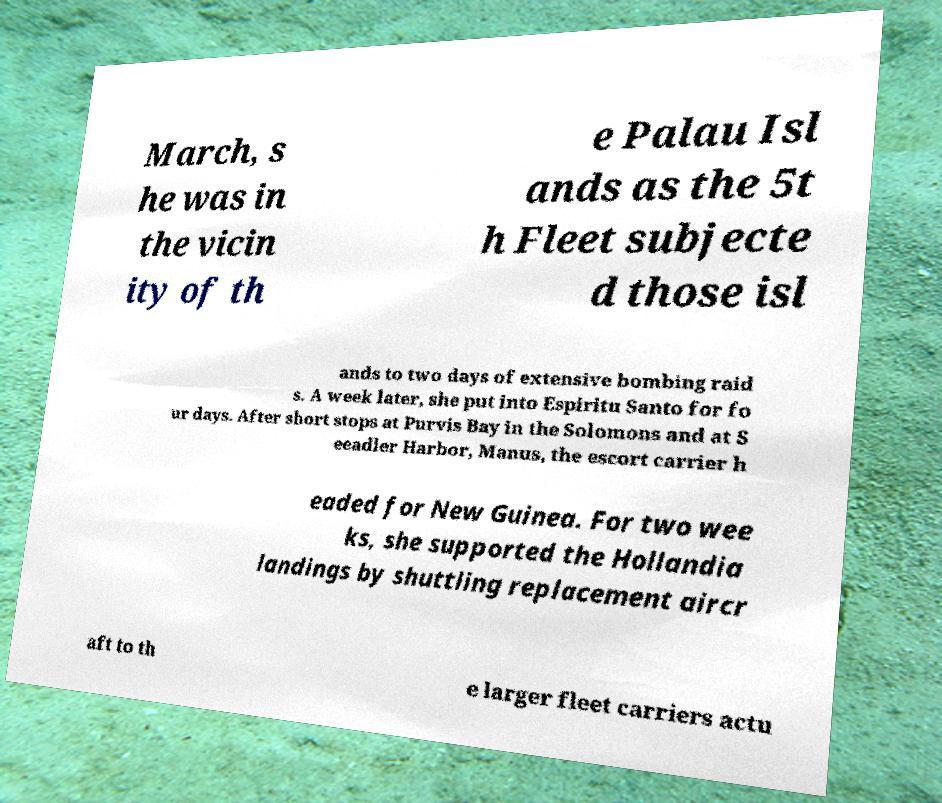I need the written content from this picture converted into text. Can you do that? March, s he was in the vicin ity of th e Palau Isl ands as the 5t h Fleet subjecte d those isl ands to two days of extensive bombing raid s. A week later, she put into Espiritu Santo for fo ur days. After short stops at Purvis Bay in the Solomons and at S eeadler Harbor, Manus, the escort carrier h eaded for New Guinea. For two wee ks, she supported the Hollandia landings by shuttling replacement aircr aft to th e larger fleet carriers actu 